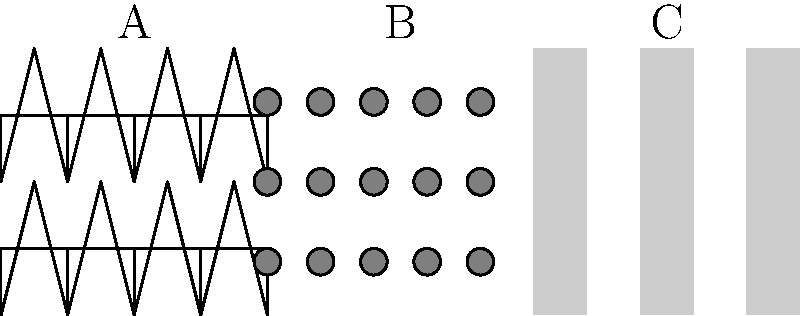As a Romanian fashion designer, you're developing a new collection inspired by traditional Romanian textiles. Which of the fabric textures shown above (A, B, or C) most closely resembles the pattern found in traditional Romanian "ie" blouses, and how might you incorporate this texture into a modern design while maintaining its cultural significance? To answer this question, we need to analyze each texture and compare it to traditional Romanian "ie" blouses:

1. Texture A: Herringbone pattern
   - Geometric, repeating V-shaped pattern
   - Not typically associated with traditional Romanian embroidery

2. Texture B: Polka Dots
   - Regular, circular pattern
   - Not characteristic of Romanian "ie" embroidery

3. Texture C: Vertical Stripes
   - Simple, linear pattern
   - Most closely resembles the vertical embroidery lines found in traditional Romanian "ie" blouses

The correct answer is Texture C (Vertical Stripes) because:
1. Traditional Romanian "ie" blouses often feature vertical embroidery lines called "râuri" (rivers).
2. These vertical lines are typically filled with intricate geometric or floral motifs.
3. The simplicity of the vertical stripes in Texture C can be seen as a modern interpretation of these traditional embroidery lines.

To incorporate this texture into a modern design while maintaining cultural significance:
1. Use the vertical stripe pattern as a base for more intricate embroidery or printed designs.
2. Combine the vertical stripes with other traditional Romanian motifs, such as diamonds or stylized flowers.
3. Apply the pattern to modern silhouettes or unconventional materials to create a fusion of traditional and contemporary styles.
4. Consider using traditional Romanian colors (red, black, white, or gold) to further emphasize the cultural connection.
5. Experiment with the width and spacing of the stripes to create various visual effects while still referencing the traditional pattern.

By choosing Texture C and thoughtfully incorporating it into modern designs, you can create a collection that honors Romanian cultural heritage while appealing to contemporary fashion sensibilities.
Answer: Texture C (Vertical Stripes) 